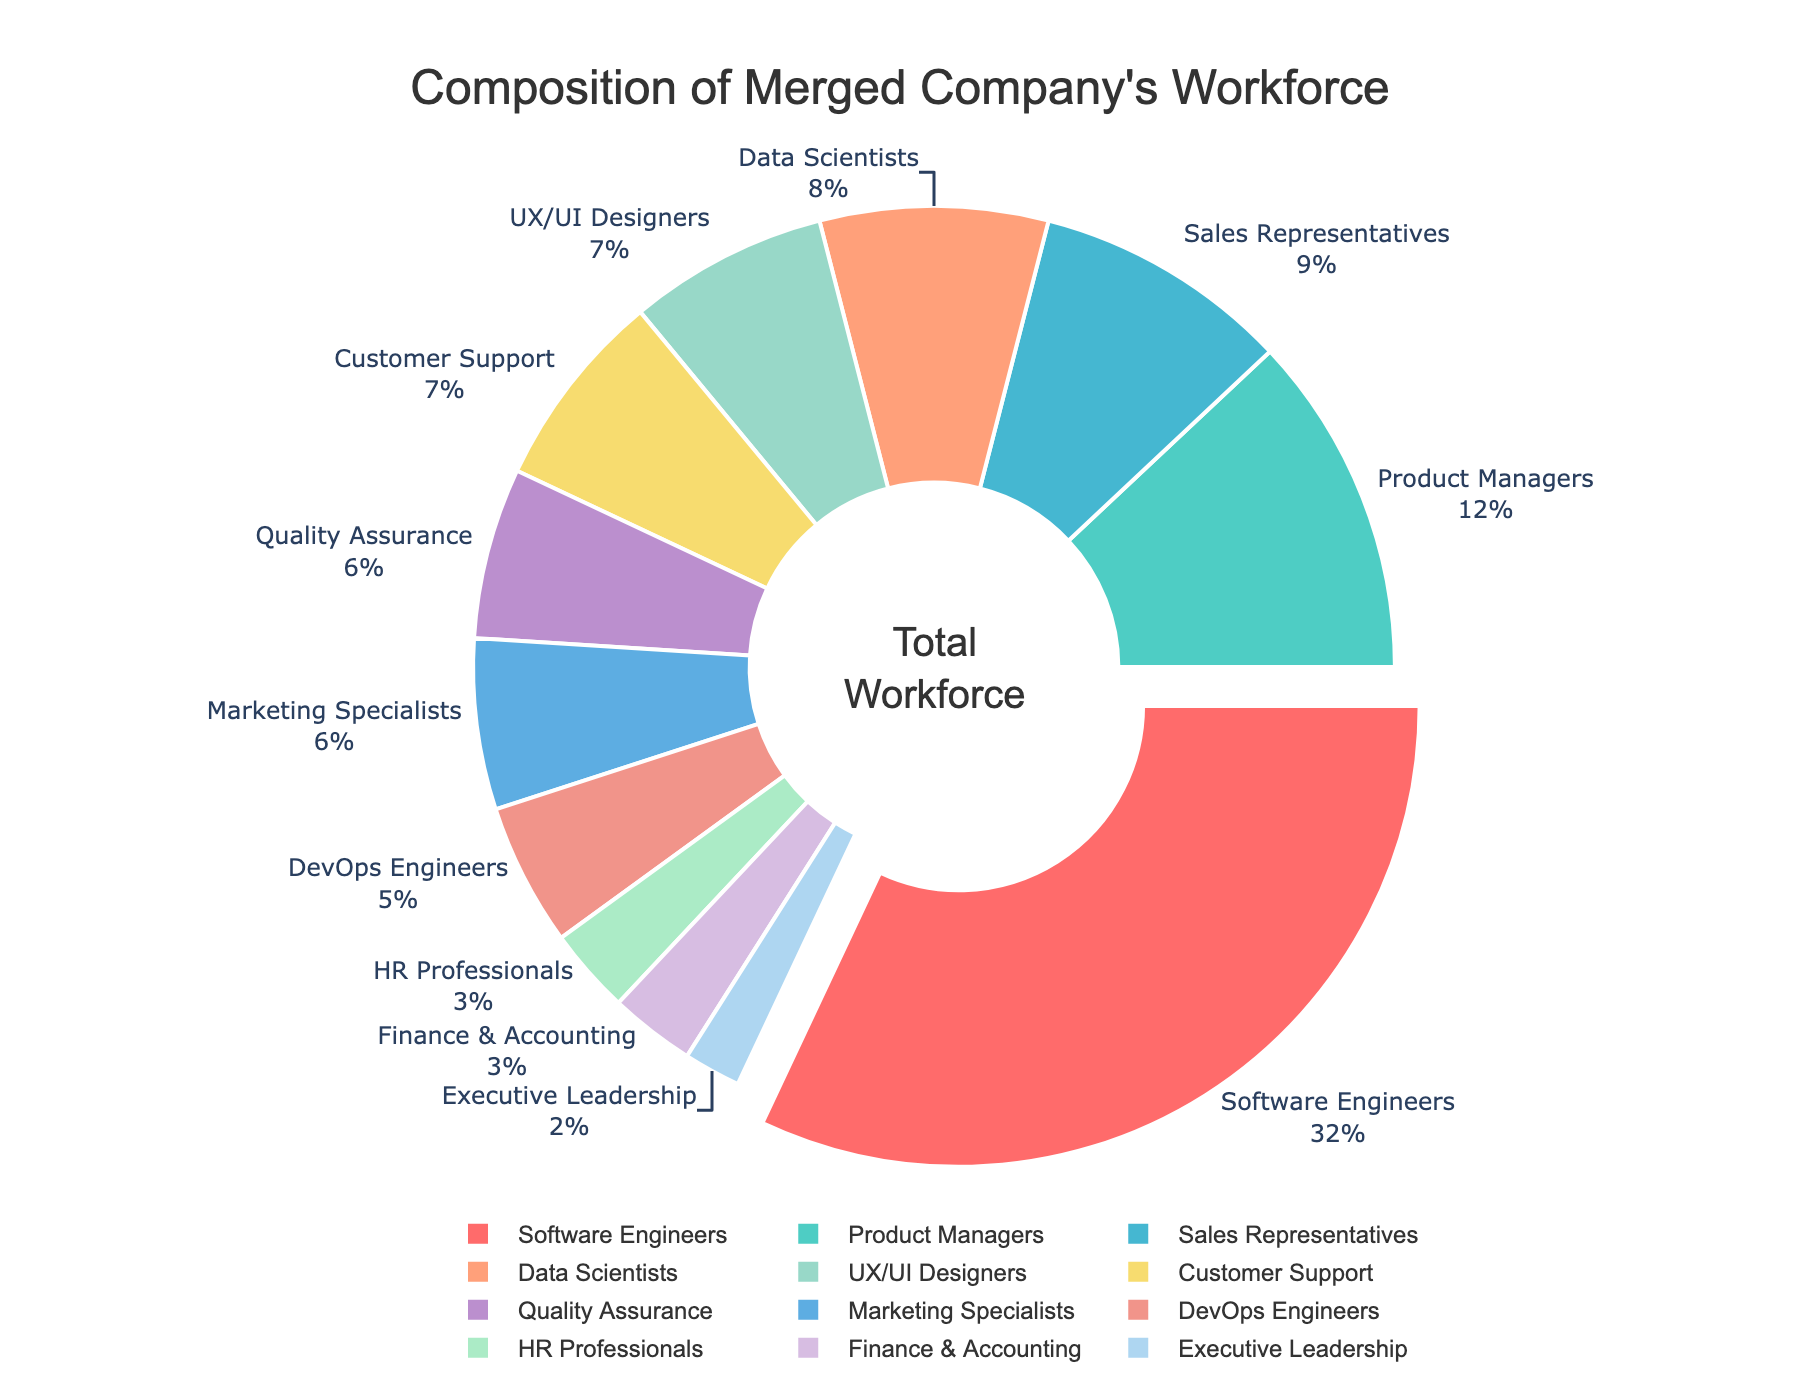What percentage of the merged company's workforce is composed of Data Scientists and UX/UI Designers combined? To find the combined percentage, we need to add the percentages of Data Scientists (8%) and UX/UI Designers (7%). This results in 8% + 7% = 15%.
Answer: 15% Which job role has the highest percentage of the workforce in the merged company? The pie chart shows that the largest segment represents the Software Engineers at 32%, which is the highest percentage.
Answer: Software Engineers How does the percentage of Sales Representatives compare to that of Marketing Specialists? To compare, the pie chart shows Sales Representatives at 9% and Marketing Specialists at 6%. Thus, Sales Representatives have a higher percentage by 3%.
Answer: Sales Representatives have 3% more What's the difference in percentage between Executive Leadership and DevOps Engineers? Executive Leadership constitutes 2% and DevOps Engineers make up 5%. Therefore, the difference in percentages is 5% - 2% = 3%.
Answer: 3% Which job roles each make up exactly 3% of the workforce? From the pie chart, HR Professionals and Finance & Accounting each account for 3% of the workforce.
Answer: HR Professionals and Finance & Accounting What is the sum of percentages of Quality Assurance, Marketing Specialists, and Customer Support roles? To find the sum, add the percentages of Quality Assurance (6%), Marketing Specialists (6%), and Customer Support (7%). The total is 6% + 6% + 7% = 19%.
Answer: 19% Do DevOps Engineers or Product Managers constitute a larger portion of the workforce? The pie chart indicates that DevOps Engineers make up 5%, while Product Managers make up 12%. Therefore, Product Managers constitute a larger portion.
Answer: Product Managers What is the percentage difference between the smallest and the largest workforce segments? The largest segment (Software Engineers) is 32%, and the smallest segment (Executive Leadership) is 2%. The difference is 32% - 2% = 30%.
Answer: 30% Of the roles shown, which has the smallest representation in the workforce? The pie chart shows Executive Leadership has the smallest segment at 2%.
Answer: Executive Leadership What is the average percentage of the workforce for HR Professionals, Finance & Accounting, and Executive Leadership? To find the average, add the percentages of HR Professionals (3%), Finance & Accounting (3%), and Executive Leadership (2%), then divide by the number of roles, which is 3. So, (3% + 3% + 2%) / 3 = 8% / 3 ≈ 2.67%.
Answer: 2.67% 